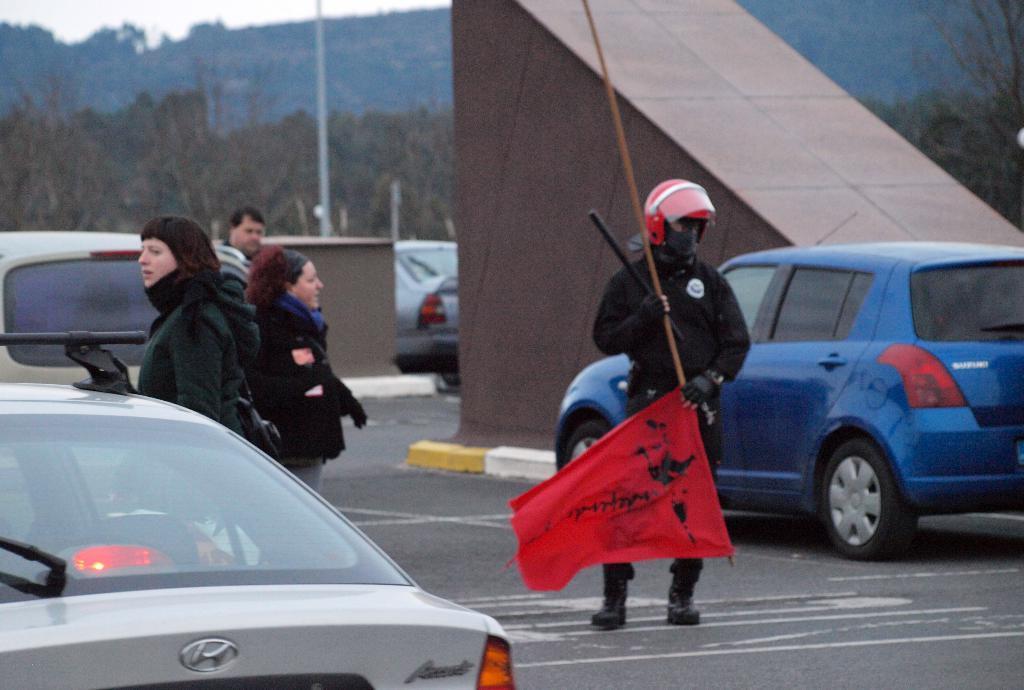Describe this image in one or two sentences. In this image there is a person wearing a helmet. He is standing on the road. He is holding a flag which is having a flag. There are vehicles on the road. Left side there are people on the road. Right side there is a wall. Behind there is a vehicle. Background there are trees. Behind there are hills. Left top there is sky. 